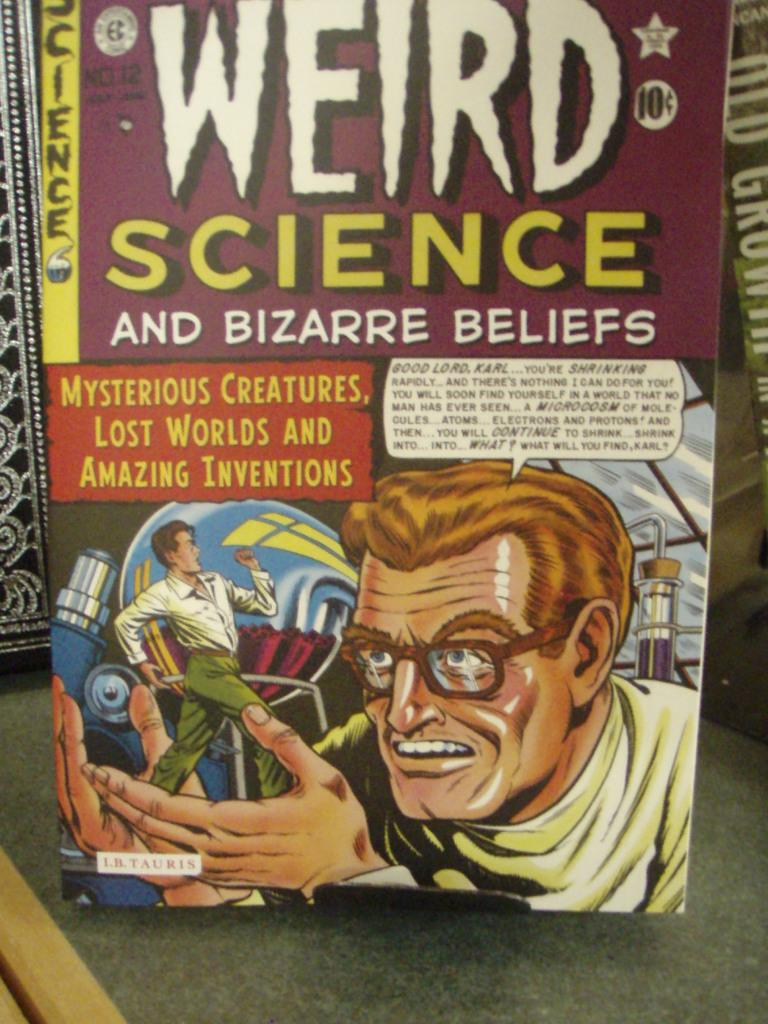<image>
Write a terse but informative summary of the picture. A Weird Science and Bizarre Beliefs comic book that was originally on sale for 10 cents 